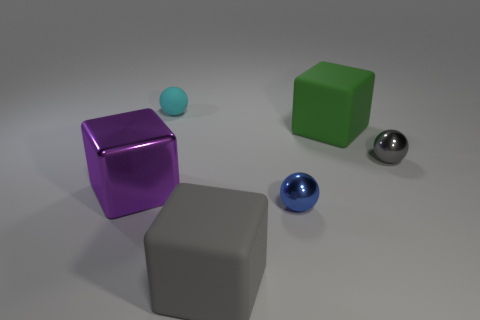Subtract all cyan cubes. Subtract all green cylinders. How many cubes are left? 3 Add 1 gray objects. How many objects exist? 7 Subtract all yellow metallic cubes. Subtract all metallic balls. How many objects are left? 4 Add 6 big green things. How many big green things are left? 7 Add 3 shiny blocks. How many shiny blocks exist? 4 Subtract 0 purple cylinders. How many objects are left? 6 